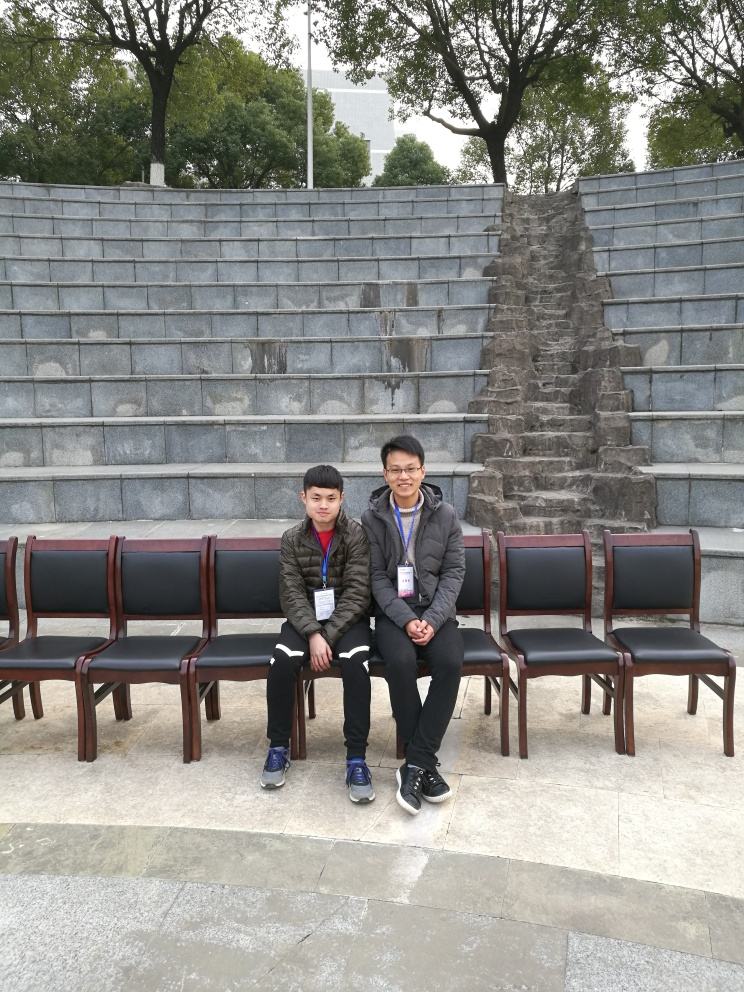Can you describe the atmosphere or mood that this image portrays? The image conveys a quiet and peaceful mood, underscored by the presence of two figures seated comfortably amidst empty chairs, and framed by the serenity of a well-maintained outdoor area with trees providing a backdrop. 